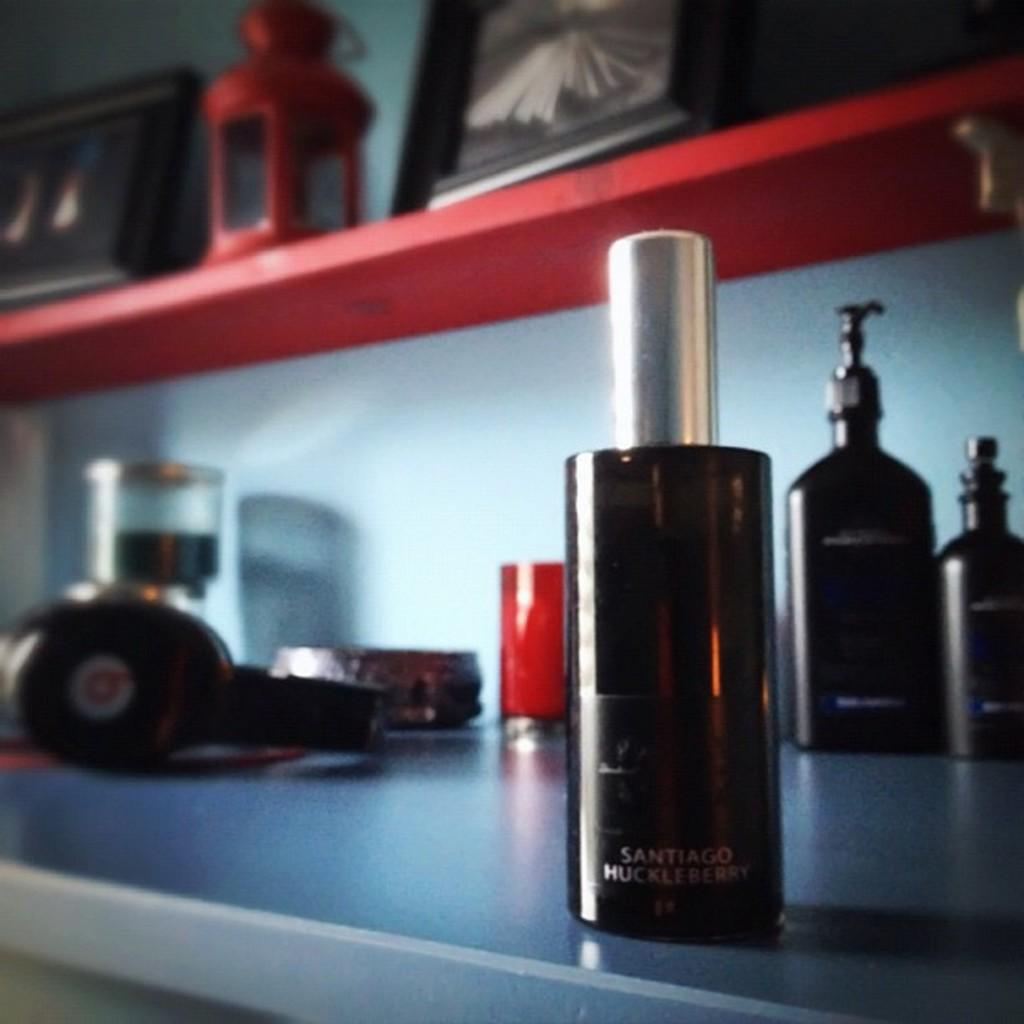<image>
Offer a succinct explanation of the picture presented. A men's grooming product in a brown bottle has the scent of Santiago Huckleberry. 